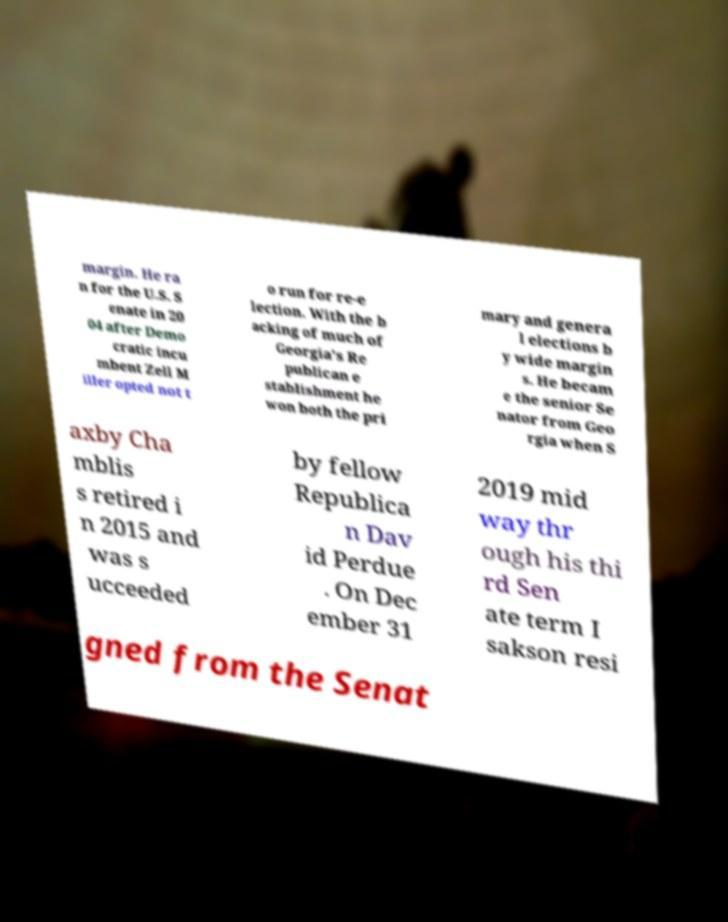For documentation purposes, I need the text within this image transcribed. Could you provide that? margin. He ra n for the U.S. S enate in 20 04 after Demo cratic incu mbent Zell M iller opted not t o run for re-e lection. With the b acking of much of Georgia's Re publican e stablishment he won both the pri mary and genera l elections b y wide margin s. He becam e the senior Se nator from Geo rgia when S axby Cha mblis s retired i n 2015 and was s ucceeded by fellow Republica n Dav id Perdue . On Dec ember 31 2019 mid way thr ough his thi rd Sen ate term I sakson resi gned from the Senat 